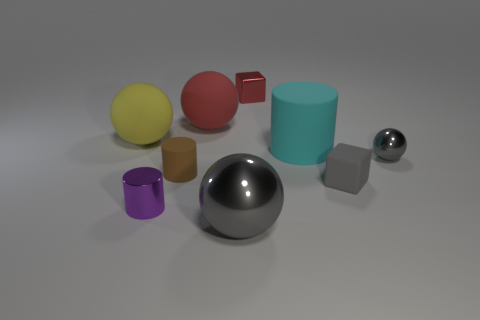There is a small ball that is the same color as the large metal sphere; what is its material?
Your answer should be compact. Metal. Is the purple thing the same size as the cyan rubber cylinder?
Your answer should be very brief. No. How many things are small metallic cylinders or big matte balls in front of the big red ball?
Give a very brief answer. 2. What is the material of the red block that is the same size as the purple metal object?
Offer a terse response. Metal. There is a tiny object that is both behind the small brown object and right of the big cyan object; what material is it made of?
Offer a very short reply. Metal. Is there a gray shiny thing to the left of the sphere that is behind the big yellow thing?
Your answer should be very brief. No. There is a matte thing that is both on the right side of the red matte ball and in front of the large cylinder; how big is it?
Your answer should be compact. Small. How many gray objects are either balls or large metal balls?
Your answer should be compact. 2. What is the shape of the other rubber thing that is the same size as the gray rubber thing?
Provide a succinct answer. Cylinder. What number of other things are there of the same color as the large cylinder?
Your answer should be very brief. 0. 